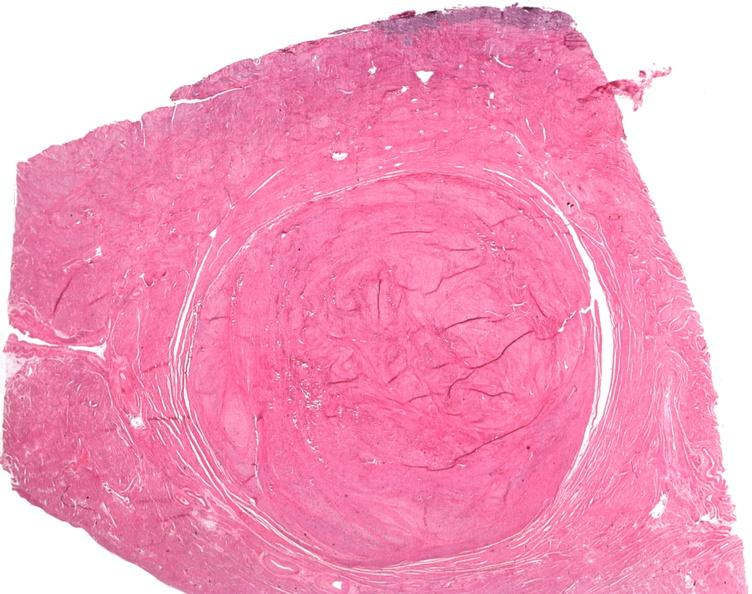what is present?
Answer the question using a single word or phrase. Female reproductive 